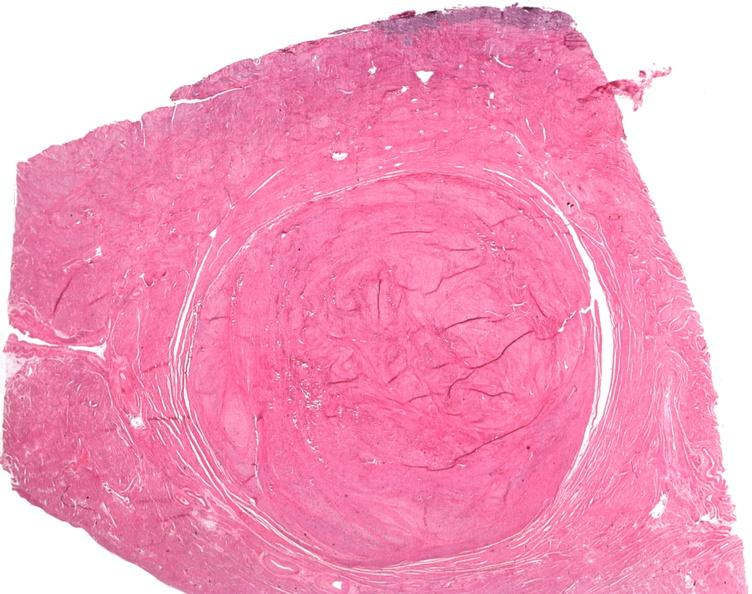what is present?
Answer the question using a single word or phrase. Female reproductive 